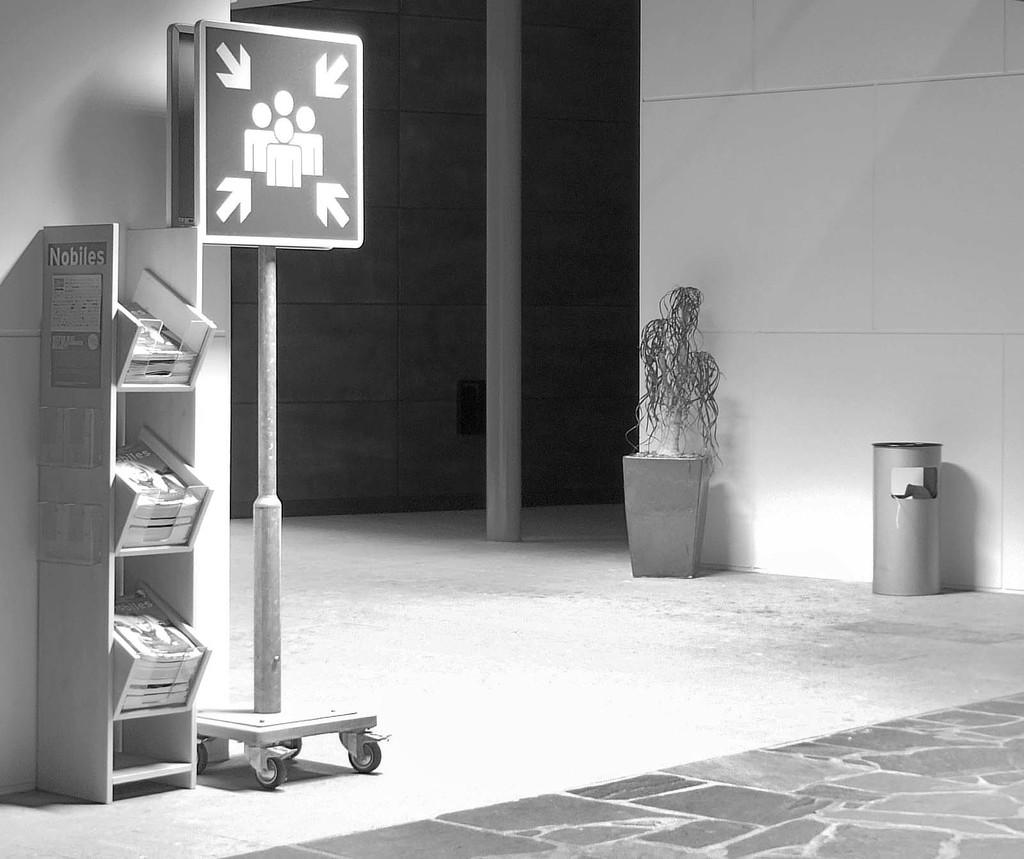What is the main object in the image? There is a board in the image. What can be seen on the board? The details on the board are not visible from the provided facts. What type of storage is present in the image? There are books on a rack in the image. What other objects can be seen in the image? There is a flower pot, a trash can, a pole, and a wall visible in the image. What is the surface on which the objects are placed? There is a floor visible at the bottom of the image. What type of quartz is used to decorate the pig in the image? There is no pig or quartz present in the image. 